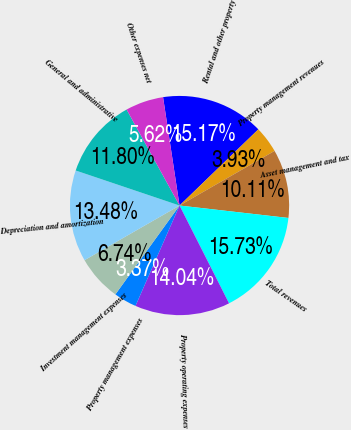<chart> <loc_0><loc_0><loc_500><loc_500><pie_chart><fcel>Rental and other property<fcel>Property management revenues<fcel>Asset management and tax<fcel>Total revenues<fcel>Property operating expenses<fcel>Property management expenses<fcel>Investment management expenses<fcel>Depreciation and amortization<fcel>General and administrative<fcel>Other expenses net<nl><fcel>15.17%<fcel>3.93%<fcel>10.11%<fcel>15.73%<fcel>14.04%<fcel>3.37%<fcel>6.74%<fcel>13.48%<fcel>11.8%<fcel>5.62%<nl></chart> 